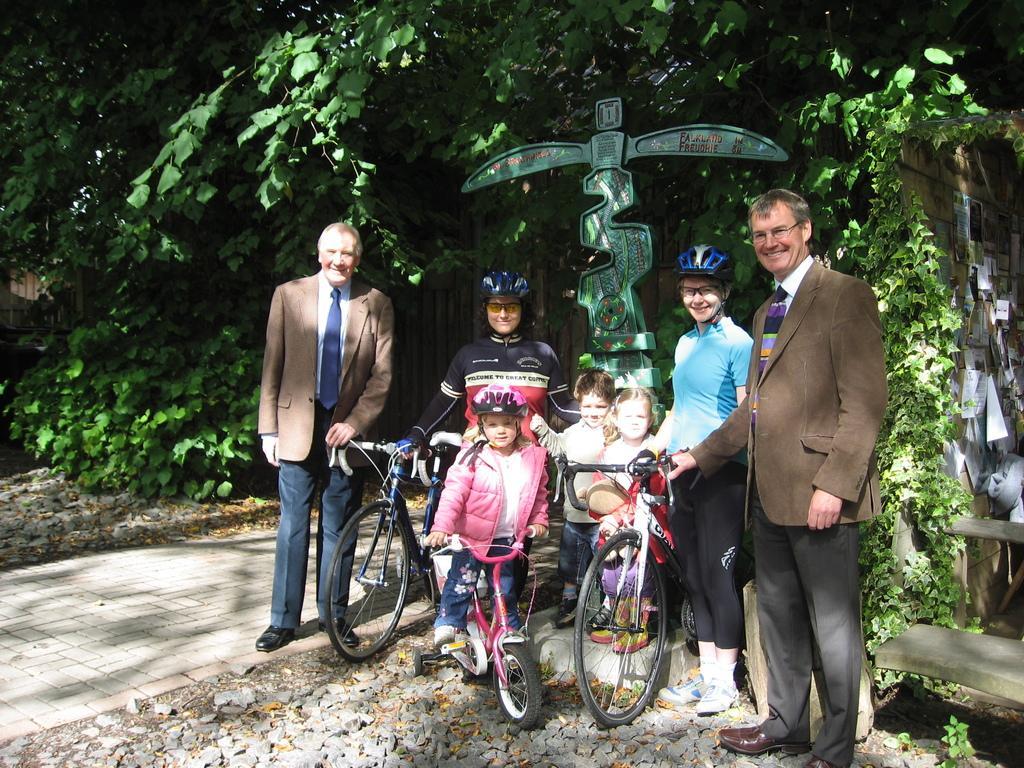Describe this image in one or two sentences. In this image I can see people standing. Few people are holding bicycles. There is a sculpture and trees at the back. 